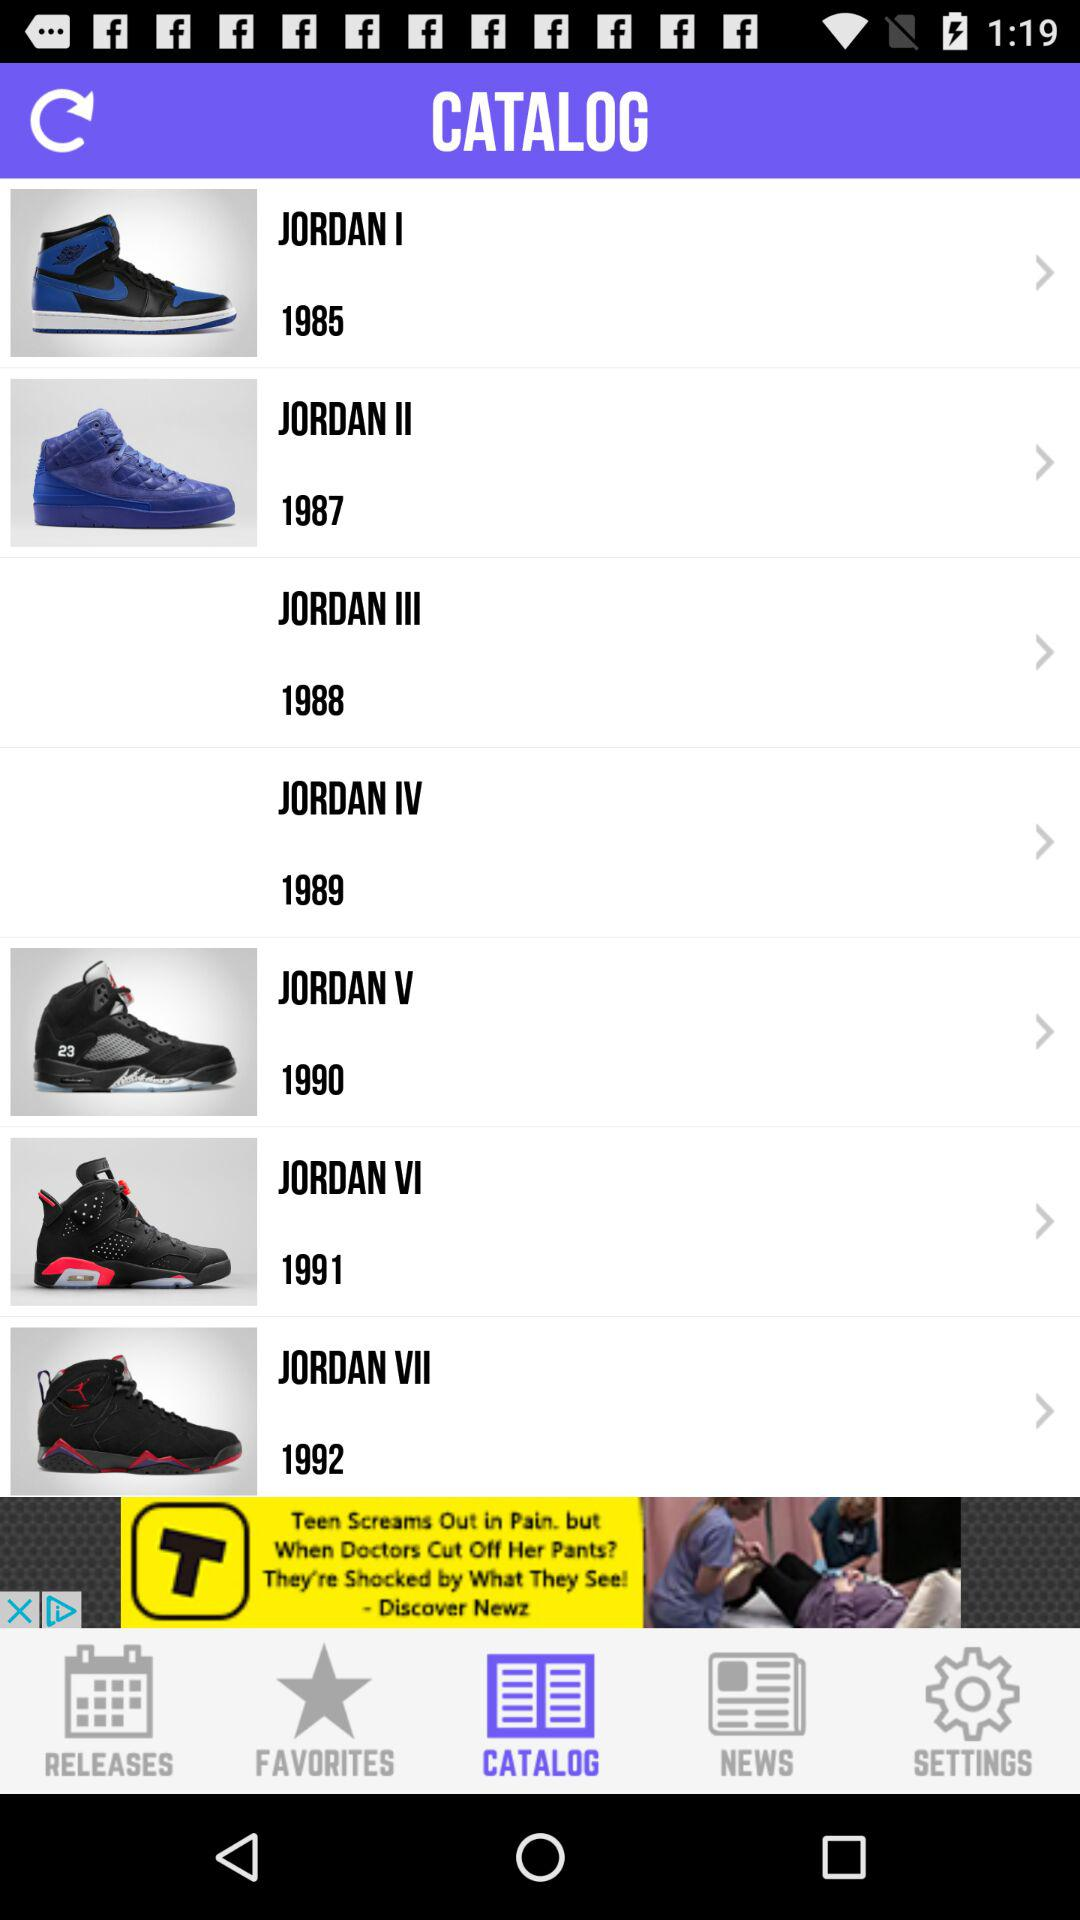Which tab is selected? The selected tab is "CATALOG". 